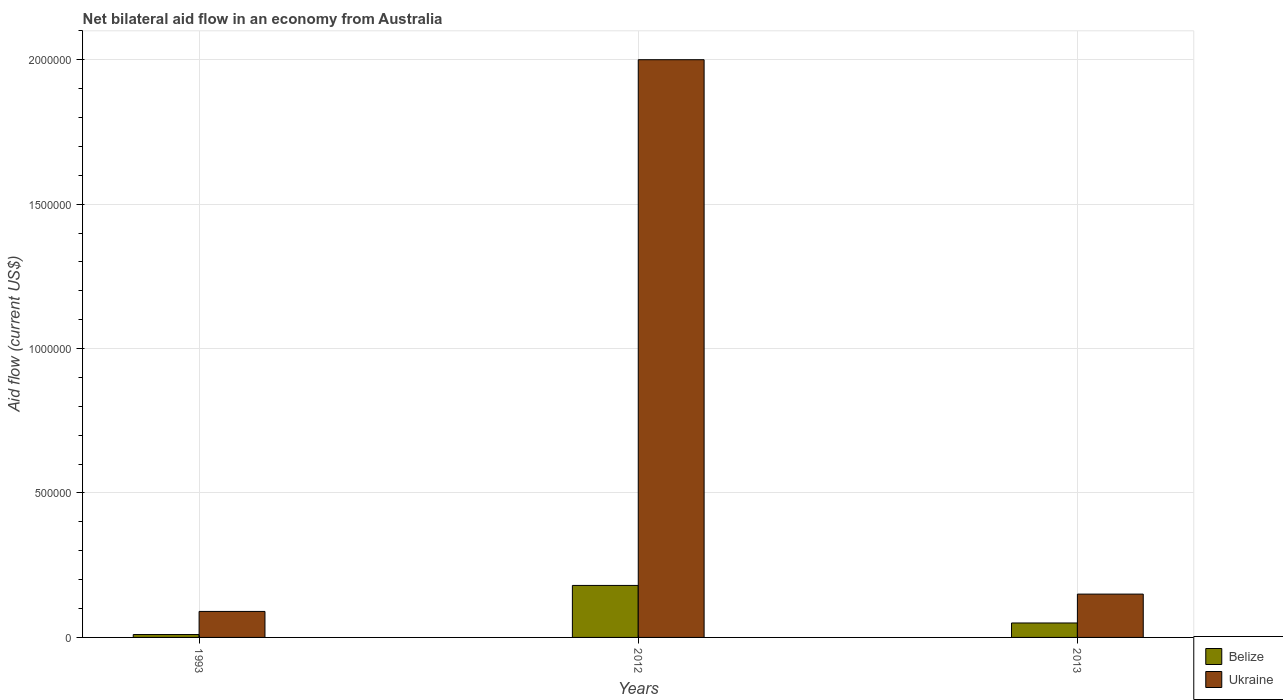How many different coloured bars are there?
Make the answer very short. 2. How many bars are there on the 3rd tick from the left?
Offer a very short reply. 2. What is the label of the 2nd group of bars from the left?
Keep it short and to the point. 2012. In which year was the net bilateral aid flow in Ukraine maximum?
Keep it short and to the point. 2012. In which year was the net bilateral aid flow in Belize minimum?
Provide a succinct answer. 1993. What is the total net bilateral aid flow in Belize in the graph?
Your answer should be compact. 2.40e+05. What is the difference between the net bilateral aid flow in Belize in 1993 and that in 2013?
Your answer should be compact. -4.00e+04. What is the average net bilateral aid flow in Ukraine per year?
Ensure brevity in your answer.  7.47e+05. In the year 2012, what is the difference between the net bilateral aid flow in Ukraine and net bilateral aid flow in Belize?
Your answer should be compact. 1.82e+06. In how many years, is the net bilateral aid flow in Ukraine greater than 1900000 US$?
Provide a succinct answer. 1. What is the ratio of the net bilateral aid flow in Ukraine in 1993 to that in 2012?
Provide a short and direct response. 0.04. What is the difference between the highest and the second highest net bilateral aid flow in Ukraine?
Your answer should be very brief. 1.85e+06. What does the 1st bar from the left in 1993 represents?
Offer a very short reply. Belize. What does the 2nd bar from the right in 2013 represents?
Keep it short and to the point. Belize. How many bars are there?
Provide a succinct answer. 6. Are all the bars in the graph horizontal?
Make the answer very short. No. Are the values on the major ticks of Y-axis written in scientific E-notation?
Provide a succinct answer. No. Does the graph contain any zero values?
Provide a short and direct response. No. Does the graph contain grids?
Ensure brevity in your answer.  Yes. How are the legend labels stacked?
Provide a succinct answer. Vertical. What is the title of the graph?
Provide a short and direct response. Net bilateral aid flow in an economy from Australia. Does "Malaysia" appear as one of the legend labels in the graph?
Offer a very short reply. No. What is the Aid flow (current US$) in Belize in 1993?
Offer a very short reply. 10000. What is the Aid flow (current US$) of Ukraine in 1993?
Provide a short and direct response. 9.00e+04. What is the Aid flow (current US$) of Belize in 2012?
Provide a succinct answer. 1.80e+05. What is the Aid flow (current US$) of Ukraine in 2012?
Your answer should be compact. 2.00e+06. Across all years, what is the maximum Aid flow (current US$) in Belize?
Provide a succinct answer. 1.80e+05. Across all years, what is the minimum Aid flow (current US$) in Ukraine?
Provide a short and direct response. 9.00e+04. What is the total Aid flow (current US$) of Belize in the graph?
Make the answer very short. 2.40e+05. What is the total Aid flow (current US$) of Ukraine in the graph?
Provide a short and direct response. 2.24e+06. What is the difference between the Aid flow (current US$) of Belize in 1993 and that in 2012?
Your answer should be very brief. -1.70e+05. What is the difference between the Aid flow (current US$) of Ukraine in 1993 and that in 2012?
Provide a succinct answer. -1.91e+06. What is the difference between the Aid flow (current US$) in Belize in 1993 and that in 2013?
Offer a terse response. -4.00e+04. What is the difference between the Aid flow (current US$) of Ukraine in 2012 and that in 2013?
Ensure brevity in your answer.  1.85e+06. What is the difference between the Aid flow (current US$) in Belize in 1993 and the Aid flow (current US$) in Ukraine in 2012?
Ensure brevity in your answer.  -1.99e+06. What is the difference between the Aid flow (current US$) in Belize in 1993 and the Aid flow (current US$) in Ukraine in 2013?
Keep it short and to the point. -1.40e+05. What is the average Aid flow (current US$) of Belize per year?
Make the answer very short. 8.00e+04. What is the average Aid flow (current US$) in Ukraine per year?
Make the answer very short. 7.47e+05. In the year 2012, what is the difference between the Aid flow (current US$) in Belize and Aid flow (current US$) in Ukraine?
Your answer should be very brief. -1.82e+06. What is the ratio of the Aid flow (current US$) in Belize in 1993 to that in 2012?
Provide a succinct answer. 0.06. What is the ratio of the Aid flow (current US$) in Ukraine in 1993 to that in 2012?
Your answer should be very brief. 0.04. What is the ratio of the Aid flow (current US$) of Belize in 2012 to that in 2013?
Make the answer very short. 3.6. What is the ratio of the Aid flow (current US$) of Ukraine in 2012 to that in 2013?
Give a very brief answer. 13.33. What is the difference between the highest and the second highest Aid flow (current US$) of Ukraine?
Provide a succinct answer. 1.85e+06. What is the difference between the highest and the lowest Aid flow (current US$) of Belize?
Your answer should be very brief. 1.70e+05. What is the difference between the highest and the lowest Aid flow (current US$) of Ukraine?
Make the answer very short. 1.91e+06. 